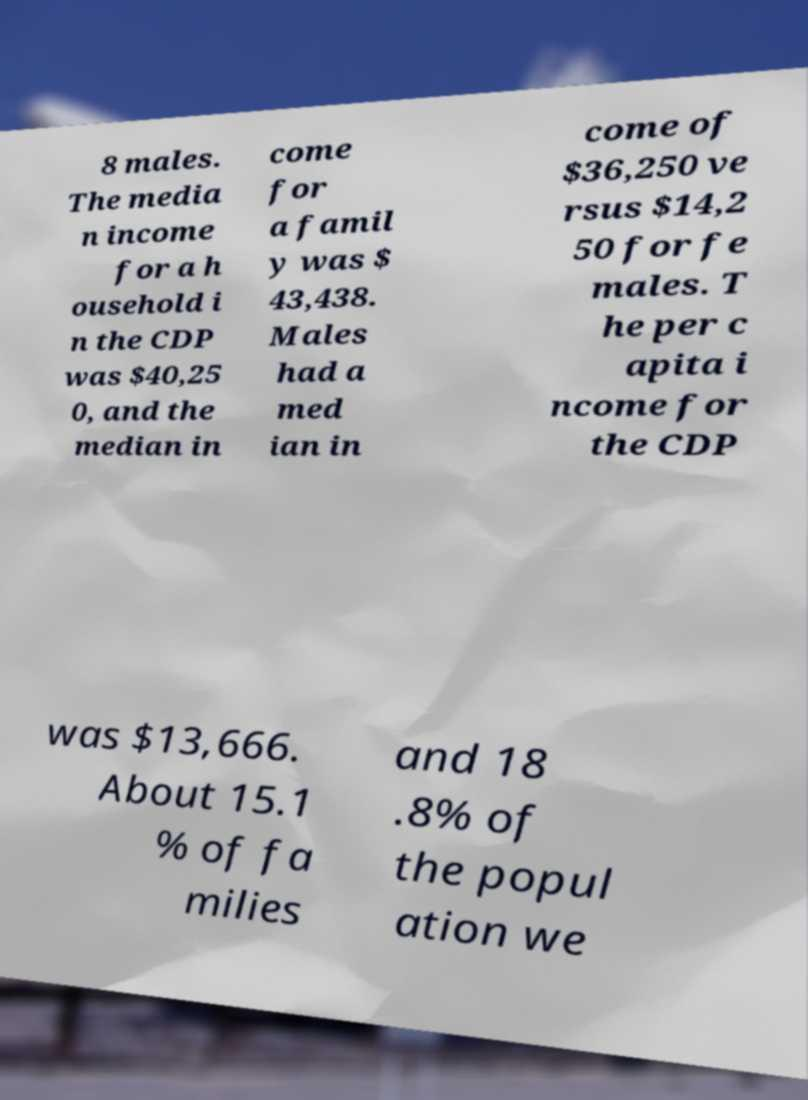I need the written content from this picture converted into text. Can you do that? 8 males. The media n income for a h ousehold i n the CDP was $40,25 0, and the median in come for a famil y was $ 43,438. Males had a med ian in come of $36,250 ve rsus $14,2 50 for fe males. T he per c apita i ncome for the CDP was $13,666. About 15.1 % of fa milies and 18 .8% of the popul ation we 